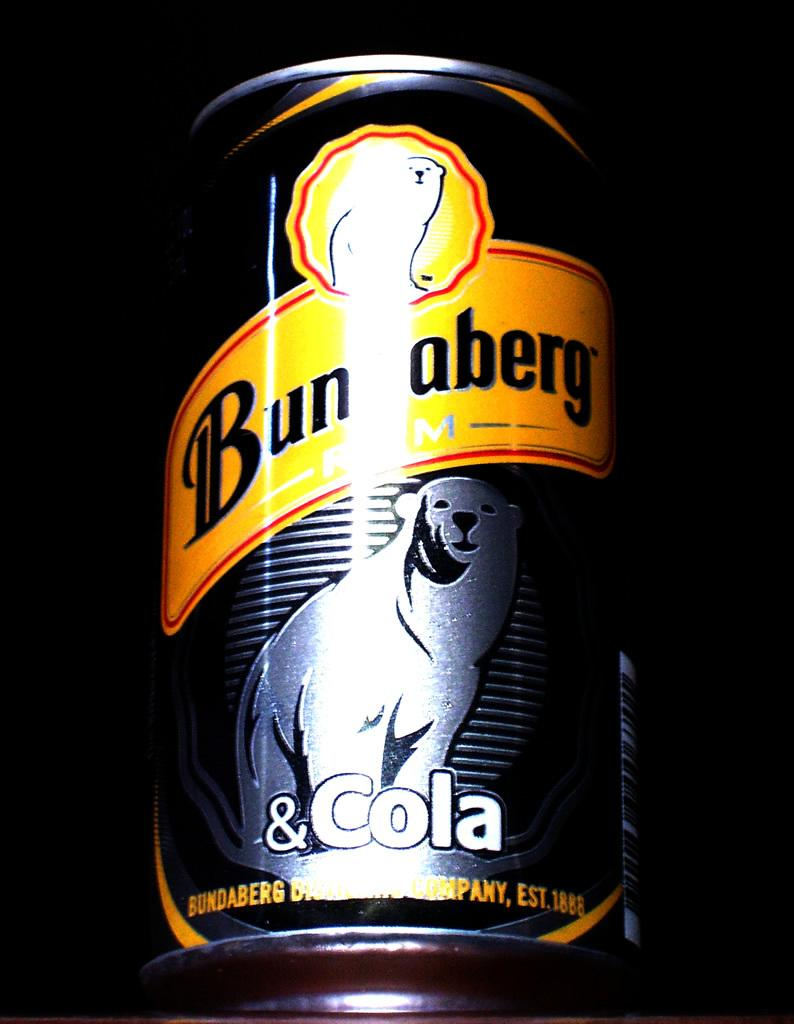<image>
Render a clear and concise summary of the photo. A Bundaberg can of drink with two bears on the can. 